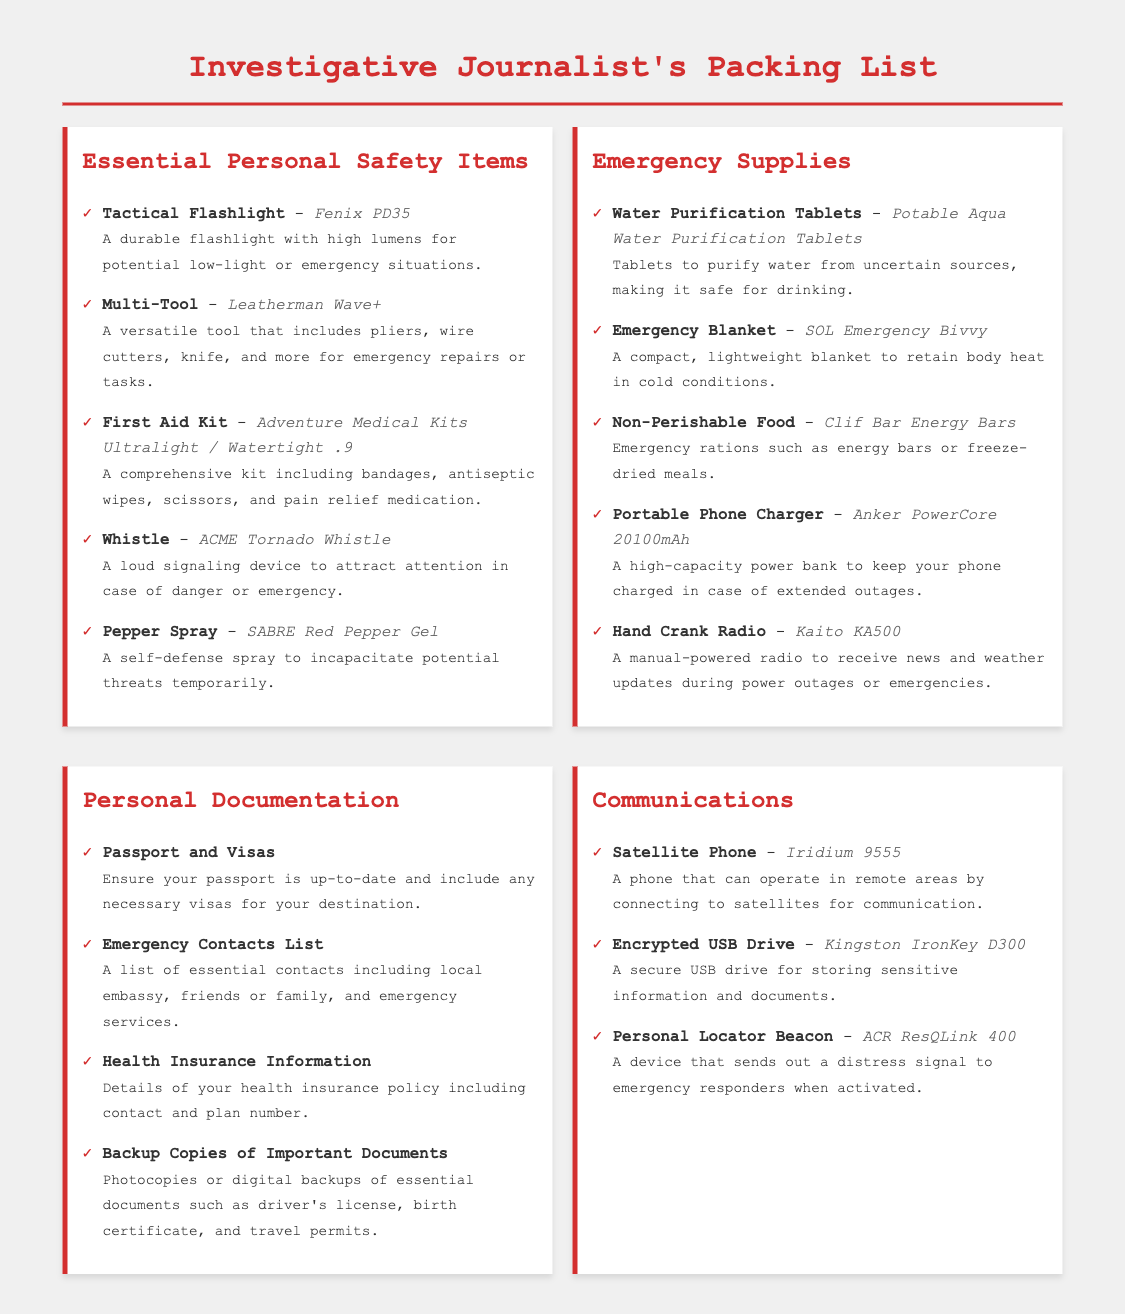What is the brand of the tactical flashlight? The document lists "Fenix PD35" as the brand of the tactical flashlight.
Answer: Fenix PD35 How many essential personal safety items are listed? The document provides a list of 5 essential personal safety items.
Answer: 5 What item is described as a loud signaling device? According to the document, the "ACME Tornado Whistle" is described as a loud signaling device.
Answer: ACME Tornado Whistle What type of emergency supply is the SOL Emergency Bivvy? The document categorizes the SOL Emergency Bivvy as an "Emergency Blanket."
Answer: Emergency Blanket What is the capacity of the portable phone charger mentioned? The document states that the Anker PowerCore has a capacity of "20100mAh."
Answer: 20100mAh Which multi-tool is highlighted for emergency repairs? The document indicates that the "Leatherman Wave+" is the highlighted multi-tool for emergency repairs.
Answer: Leatherman Wave+ How many items are categorized under Emergency Supplies? The document contains 5 items listed under Emergency Supplies.
Answer: 5 What communication device operates in remote areas? The document mentions the "Iridium 9555" as the communication device that operates in remote areas.
Answer: Iridium 9555 